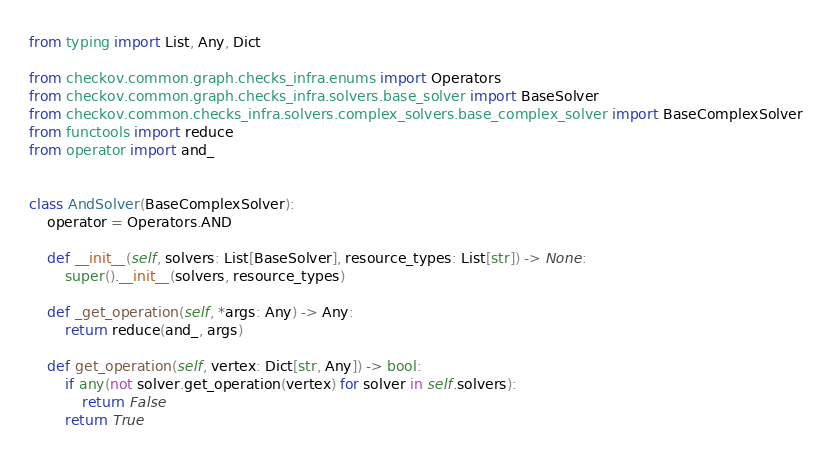<code> <loc_0><loc_0><loc_500><loc_500><_Python_>from typing import List, Any, Dict

from checkov.common.graph.checks_infra.enums import Operators
from checkov.common.graph.checks_infra.solvers.base_solver import BaseSolver
from checkov.common.checks_infra.solvers.complex_solvers.base_complex_solver import BaseComplexSolver
from functools import reduce
from operator import and_


class AndSolver(BaseComplexSolver):
    operator = Operators.AND

    def __init__(self, solvers: List[BaseSolver], resource_types: List[str]) -> None:
        super().__init__(solvers, resource_types)

    def _get_operation(self, *args: Any) -> Any:
        return reduce(and_, args)

    def get_operation(self, vertex: Dict[str, Any]) -> bool:
        if any(not solver.get_operation(vertex) for solver in self.solvers):
            return False
        return True
</code> 